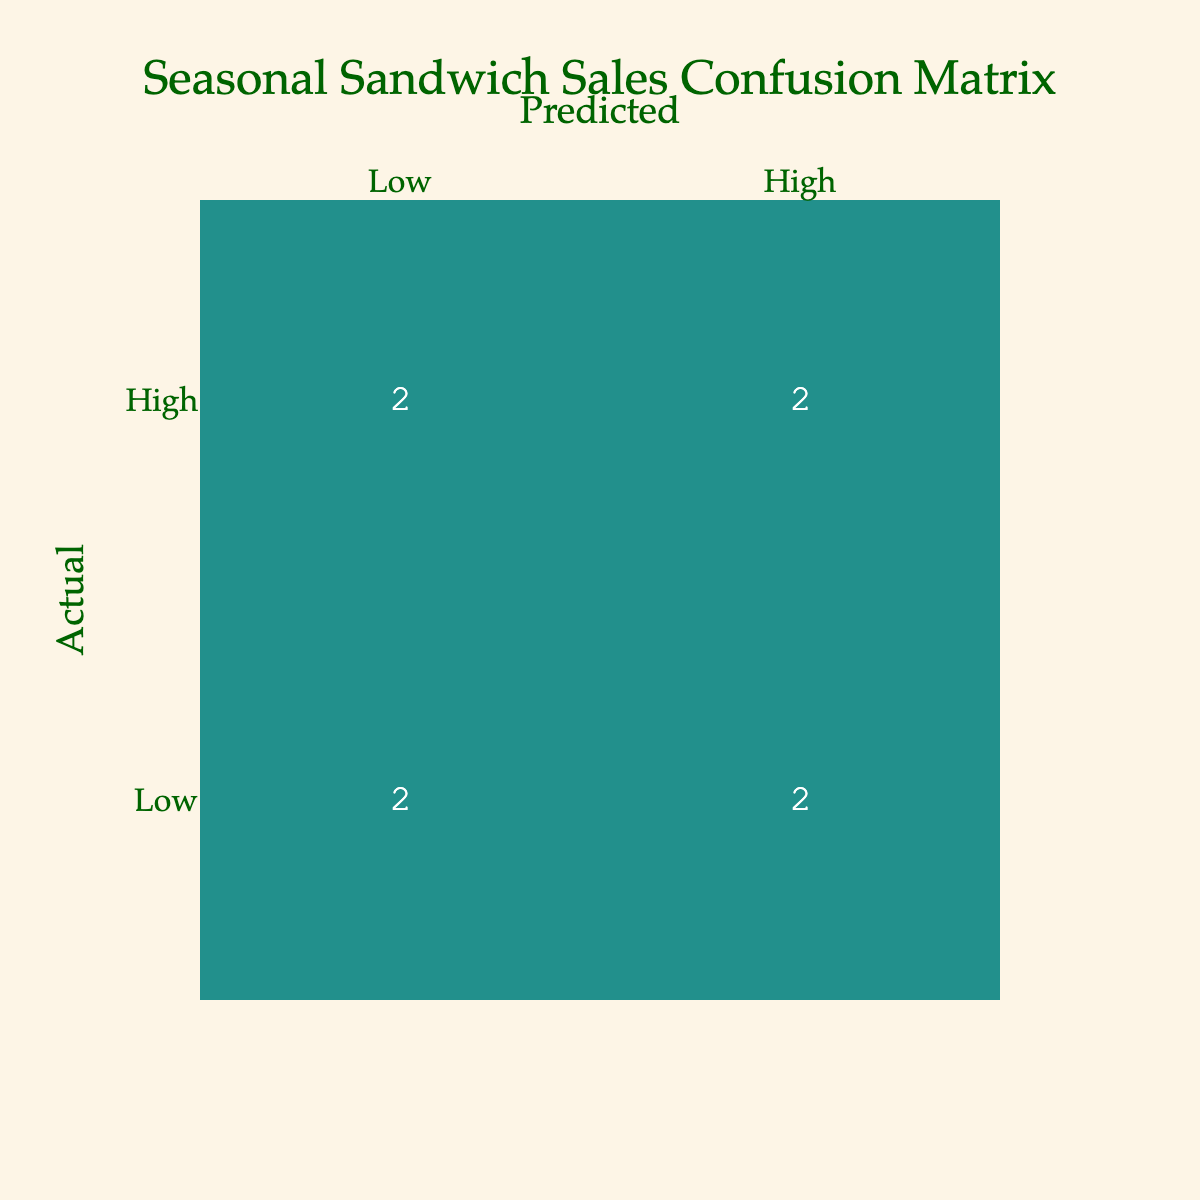What is the actual sales count for the "Spicy Pumpkin Caprese" sandwich? The table indicates that the actual sales for the "Spicy Pumpkin Caprese" sandwich is labeled as "Low." This means that in the confusion matrix, it corresponds to the "Low" row and specified sandwich.
Answer: Low How many sandwiches had high predicted sales but ended up being low in actual sales? The "High" predicted sales row shows count values that lead to "Low" actual sales. In this case, there are two sandwiches: "Smoky Maple Bacon" and "Chipotle Chicken Frenzy." Thus, the total count is 2.
Answer: 2 Did any sandwiches have both high predicted and actual sales? The table shows that the "Avocado Toast Delight" and "Turkey Cranberry Bliss" sandwiches have both predicted and actual sales labeled as "High." Thus, the answer is yes.
Answer: Yes What is the total number of actual low sales for all seasons? The actual low sales are represented by the "Low" row in the confusion matrix. The count of low sales includes "Smoky Maple Bacon," "Chipotle Chicken Frenzy," "Spicy Pumpkin Caprese," and "Herbed Tomato Grilled Cheese," totaling 4 sandwiches.
Answer: 4 Is there any sandwich that was predicted to have low sales but actually had high sales? Referring to the data, the "Roasted Beet & Goat Cheese" and "Grilled Peach & Brie" sandwiches were predicted as "Low" but had "High" actual sales. This confirms the presence of such sandwiches.
Answer: Yes How many sandwiches were both predicted and had low actual sales for the Winter season? For the Winter season, the sandwiches that were predicted to have low sales are checked against the actual sales. Only the "Spicy Pumpkin Caprese" sandwich fits this criterion. Thus, there is just one sandwich.
Answer: 1 What is the break-even point for predicted high sales versus actual high sales? The confusion matrix shows that there are 2 sandwiches that had high predicted but low actual sales ("Smoky Maple Bacon" and "Chipotle Chicken Frenzy") and 2 sandwiches that had high predicted and high actual sales ("Avocado Toast Delight" and "Turkey Cranberry Bliss"). Therefore, the break-even occurs where both metrics align perfectly, indicating their balance.
Answer: 2 How can the performance of the "Herbed Tomato Grilled Cheese" sandwich be characterized? The "Herbed Tomato Grilled Cheese" sandwich is in the actual low sales category and was also predicted to be low sales, indicating that its performance is consistent with expectations but not successful in sales.
Answer: Predictably low performance What sandwiches generated high actual sales but were predicted low? In the confusion matrix data, the "Grilled Peach & Brie" and "Roasted Beet & Goat Cheese" sandwiches fall under actual high sales while being predicted as low, thus indicating a strong market surprise for these sandwiches.
Answer: Grilled Peach & Brie, Roasted Beet & Goat Cheese 